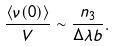Convert formula to latex. <formula><loc_0><loc_0><loc_500><loc_500>\frac { \left < \nu ( 0 ) \right > } { V } \sim \frac { n _ { 3 } } { \Delta \lambda b } .</formula> 